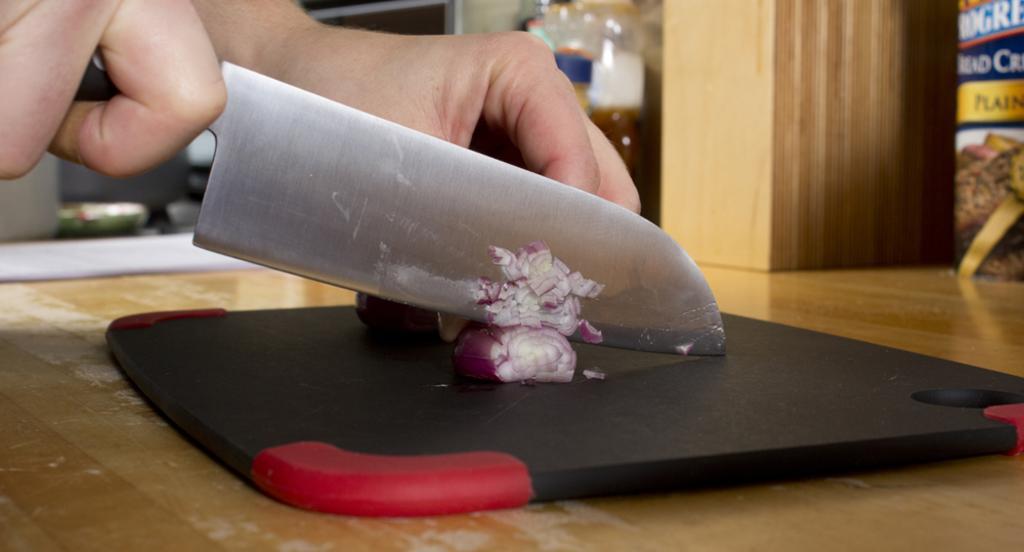Describe this image in one or two sentences. In this image I can see a hand of a person chopping onion with knife on a chopping board. 